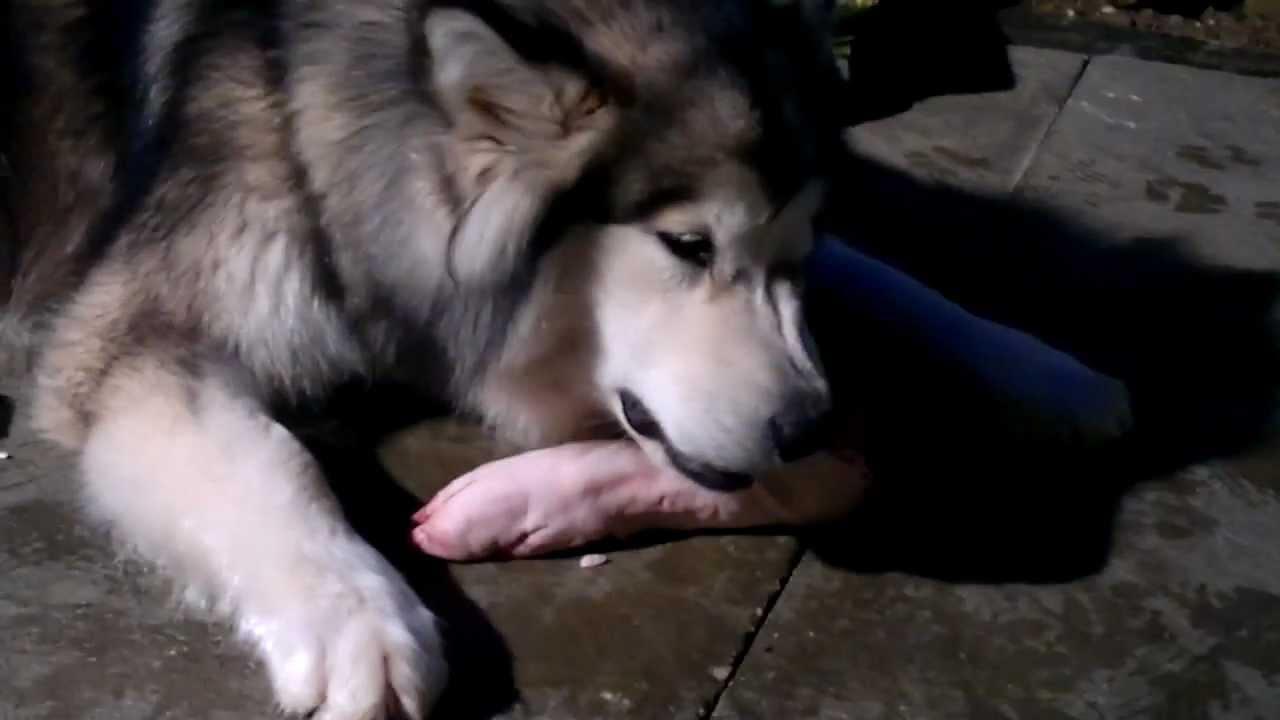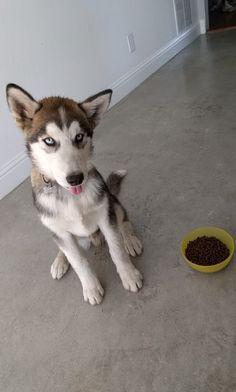The first image is the image on the left, the second image is the image on the right. For the images displayed, is the sentence "A dog can be seen interacting with a severed limb portion of another animal." factually correct? Answer yes or no. Yes. The first image is the image on the left, the second image is the image on the right. Analyze the images presented: Is the assertion "Each image shows a single husky dog, and one of the dogs pictured is in a reclining pose with its muzzle over a pinkish 'bone' and at least one paw near the object." valid? Answer yes or no. Yes. 